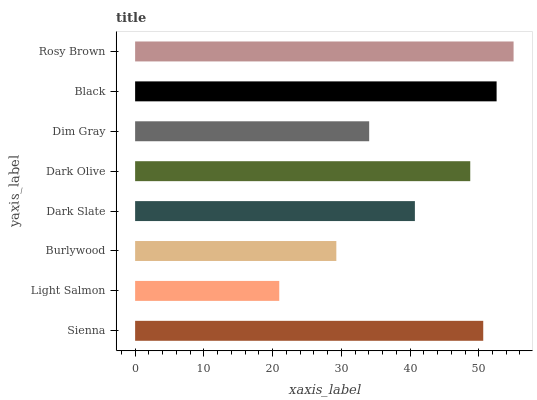Is Light Salmon the minimum?
Answer yes or no. Yes. Is Rosy Brown the maximum?
Answer yes or no. Yes. Is Burlywood the minimum?
Answer yes or no. No. Is Burlywood the maximum?
Answer yes or no. No. Is Burlywood greater than Light Salmon?
Answer yes or no. Yes. Is Light Salmon less than Burlywood?
Answer yes or no. Yes. Is Light Salmon greater than Burlywood?
Answer yes or no. No. Is Burlywood less than Light Salmon?
Answer yes or no. No. Is Dark Olive the high median?
Answer yes or no. Yes. Is Dark Slate the low median?
Answer yes or no. Yes. Is Dim Gray the high median?
Answer yes or no. No. Is Rosy Brown the low median?
Answer yes or no. No. 